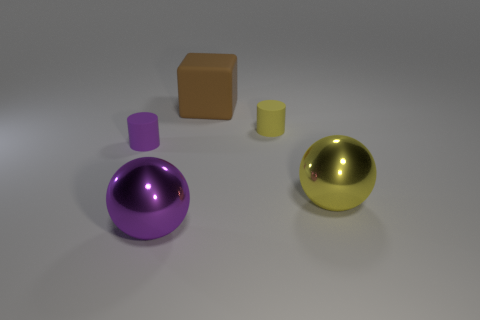There is a purple sphere that is the same size as the brown block; what material is it? The purple sphere appears to have a shiny, reflective surface which is characteristic of metallic materials. It is likely intended to represent a metal sphere in the context of this image. 